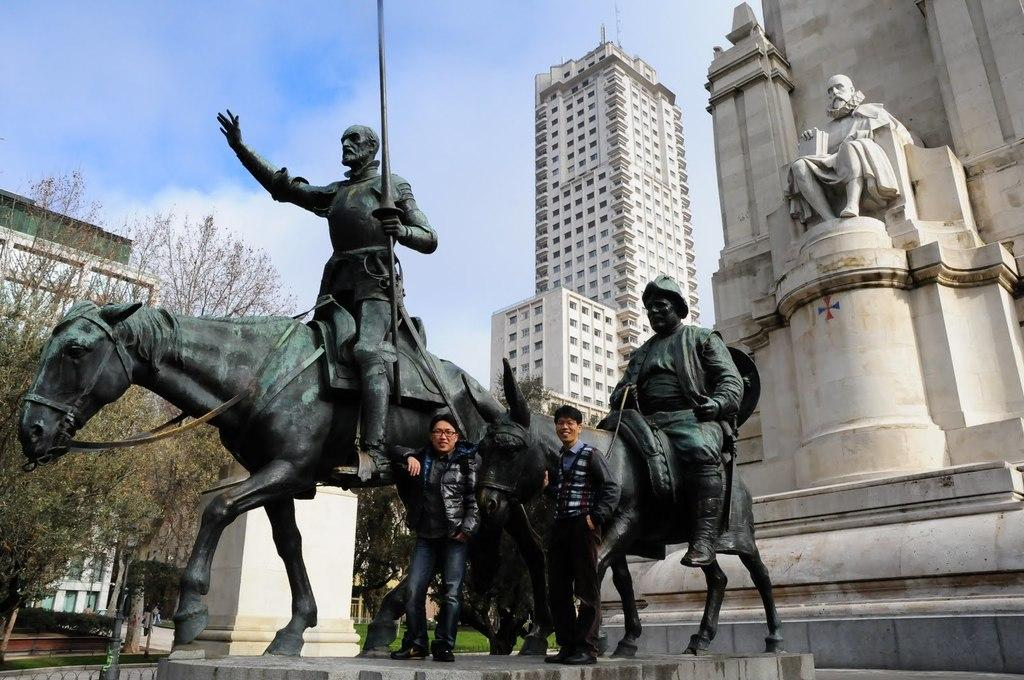What can be seen in the image besides the statues? Two persons are standing near the statues. What is visible in the background of the image? There are trees, buildings, and the sky visible in the background of the image. What type of train can be seen passing by the statues in the image? There is no train present in the image; it only features statues, two persons, and the background elements. 